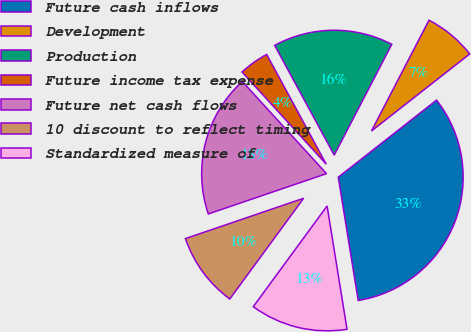Convert chart. <chart><loc_0><loc_0><loc_500><loc_500><pie_chart><fcel>Future cash inflows<fcel>Development<fcel>Production<fcel>Future income tax expense<fcel>Future net cash flows<fcel>10 discount to reflect timing<fcel>Standardized measure of<nl><fcel>33.04%<fcel>6.79%<fcel>15.54%<fcel>3.87%<fcel>18.45%<fcel>9.7%<fcel>12.62%<nl></chart> 